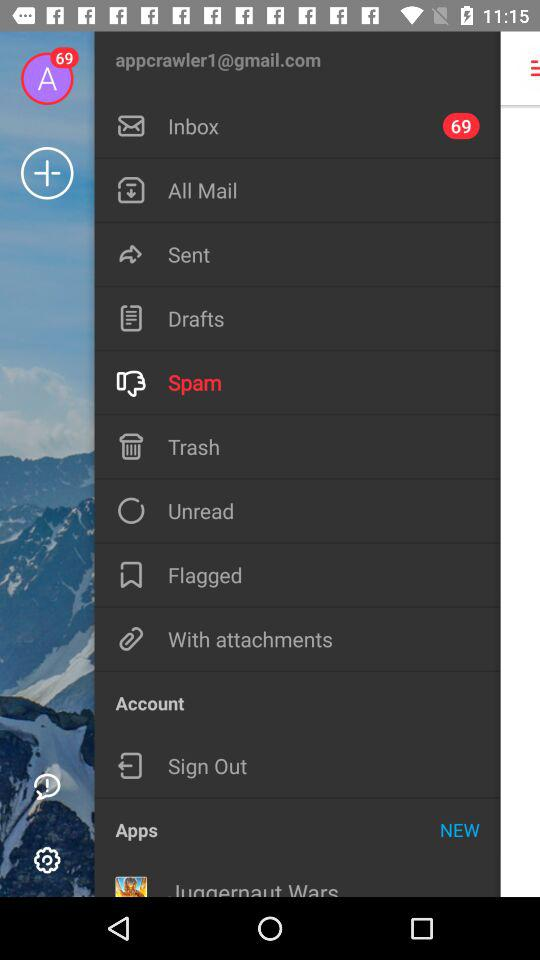Which is the selected item in the menu? The selected item in the menu is "Spam". 